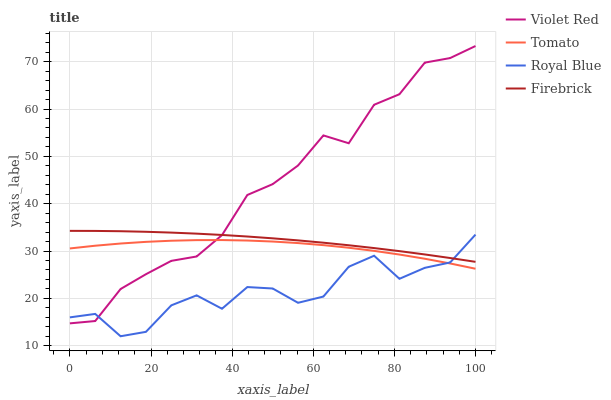Does Royal Blue have the minimum area under the curve?
Answer yes or no. Yes. Does Violet Red have the maximum area under the curve?
Answer yes or no. Yes. Does Violet Red have the minimum area under the curve?
Answer yes or no. No. Does Royal Blue have the maximum area under the curve?
Answer yes or no. No. Is Firebrick the smoothest?
Answer yes or no. Yes. Is Royal Blue the roughest?
Answer yes or no. Yes. Is Violet Red the smoothest?
Answer yes or no. No. Is Violet Red the roughest?
Answer yes or no. No. Does Violet Red have the lowest value?
Answer yes or no. No. Does Violet Red have the highest value?
Answer yes or no. Yes. Does Royal Blue have the highest value?
Answer yes or no. No. Is Tomato less than Firebrick?
Answer yes or no. Yes. Is Firebrick greater than Tomato?
Answer yes or no. Yes. Does Violet Red intersect Firebrick?
Answer yes or no. Yes. Is Violet Red less than Firebrick?
Answer yes or no. No. Is Violet Red greater than Firebrick?
Answer yes or no. No. Does Tomato intersect Firebrick?
Answer yes or no. No. 